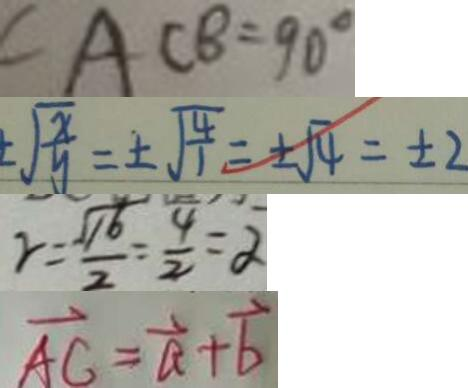Convert formula to latex. <formula><loc_0><loc_0><loc_500><loc_500>\angle A C B = 9 0 ^ { \circ } 
 \sqrt { \frac { x } { y } } = \pm \sqrt { \frac { 4 } { 1 } } = \pm \sqrt { 4 } = \pm 2 
 \gamma = \frac { \sqrt { 1 6 } } { 2 } = \frac { 4 } { 2 } = \alpha 
 \overrightarrow { A C } = \overrightarrow { a } + \overrightarrow { b }</formula> 